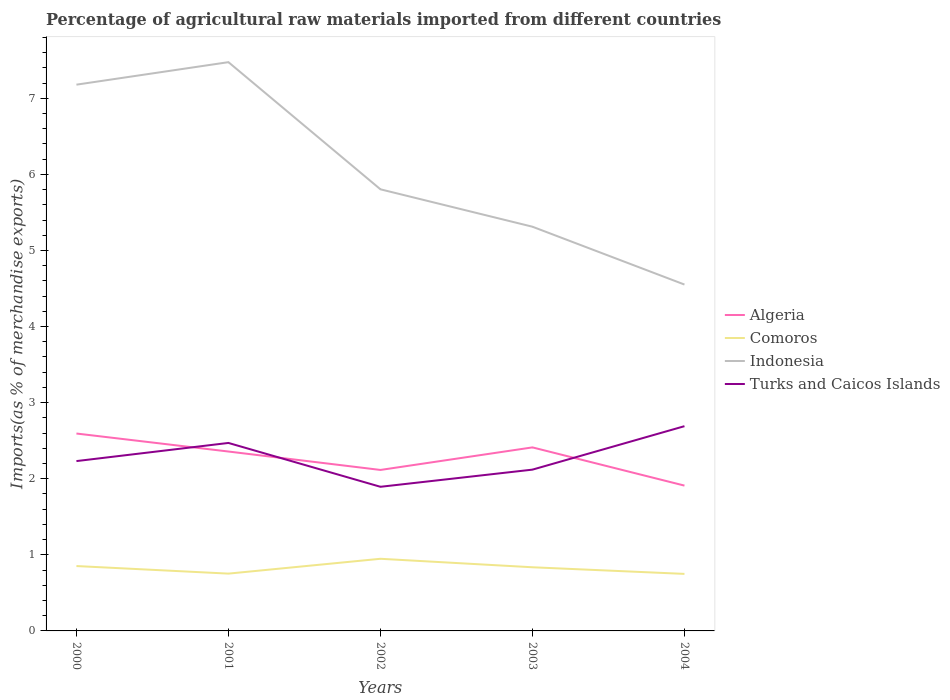How many different coloured lines are there?
Your answer should be compact. 4. Across all years, what is the maximum percentage of imports to different countries in Algeria?
Ensure brevity in your answer.  1.91. In which year was the percentage of imports to different countries in Indonesia maximum?
Ensure brevity in your answer.  2004. What is the total percentage of imports to different countries in Turks and Caicos Islands in the graph?
Ensure brevity in your answer.  0.58. What is the difference between the highest and the second highest percentage of imports to different countries in Algeria?
Provide a succinct answer. 0.68. Does the graph contain grids?
Give a very brief answer. No. Where does the legend appear in the graph?
Ensure brevity in your answer.  Center right. How are the legend labels stacked?
Ensure brevity in your answer.  Vertical. What is the title of the graph?
Keep it short and to the point. Percentage of agricultural raw materials imported from different countries. What is the label or title of the X-axis?
Make the answer very short. Years. What is the label or title of the Y-axis?
Your response must be concise. Imports(as % of merchandise exports). What is the Imports(as % of merchandise exports) in Algeria in 2000?
Provide a short and direct response. 2.59. What is the Imports(as % of merchandise exports) in Comoros in 2000?
Your answer should be very brief. 0.85. What is the Imports(as % of merchandise exports) of Indonesia in 2000?
Your answer should be compact. 7.18. What is the Imports(as % of merchandise exports) in Turks and Caicos Islands in 2000?
Make the answer very short. 2.23. What is the Imports(as % of merchandise exports) in Algeria in 2001?
Provide a succinct answer. 2.36. What is the Imports(as % of merchandise exports) in Comoros in 2001?
Keep it short and to the point. 0.75. What is the Imports(as % of merchandise exports) in Indonesia in 2001?
Provide a short and direct response. 7.47. What is the Imports(as % of merchandise exports) of Turks and Caicos Islands in 2001?
Provide a short and direct response. 2.47. What is the Imports(as % of merchandise exports) of Algeria in 2002?
Provide a short and direct response. 2.12. What is the Imports(as % of merchandise exports) in Comoros in 2002?
Provide a succinct answer. 0.95. What is the Imports(as % of merchandise exports) of Indonesia in 2002?
Your answer should be very brief. 5.8. What is the Imports(as % of merchandise exports) in Turks and Caicos Islands in 2002?
Ensure brevity in your answer.  1.89. What is the Imports(as % of merchandise exports) in Algeria in 2003?
Provide a succinct answer. 2.41. What is the Imports(as % of merchandise exports) of Comoros in 2003?
Provide a succinct answer. 0.84. What is the Imports(as % of merchandise exports) in Indonesia in 2003?
Make the answer very short. 5.31. What is the Imports(as % of merchandise exports) of Turks and Caicos Islands in 2003?
Keep it short and to the point. 2.12. What is the Imports(as % of merchandise exports) of Algeria in 2004?
Keep it short and to the point. 1.91. What is the Imports(as % of merchandise exports) in Comoros in 2004?
Your answer should be very brief. 0.75. What is the Imports(as % of merchandise exports) in Indonesia in 2004?
Your answer should be very brief. 4.55. What is the Imports(as % of merchandise exports) in Turks and Caicos Islands in 2004?
Offer a terse response. 2.69. Across all years, what is the maximum Imports(as % of merchandise exports) in Algeria?
Offer a very short reply. 2.59. Across all years, what is the maximum Imports(as % of merchandise exports) of Comoros?
Your answer should be very brief. 0.95. Across all years, what is the maximum Imports(as % of merchandise exports) in Indonesia?
Offer a very short reply. 7.47. Across all years, what is the maximum Imports(as % of merchandise exports) in Turks and Caicos Islands?
Your answer should be compact. 2.69. Across all years, what is the minimum Imports(as % of merchandise exports) in Algeria?
Keep it short and to the point. 1.91. Across all years, what is the minimum Imports(as % of merchandise exports) in Comoros?
Your response must be concise. 0.75. Across all years, what is the minimum Imports(as % of merchandise exports) in Indonesia?
Make the answer very short. 4.55. Across all years, what is the minimum Imports(as % of merchandise exports) of Turks and Caicos Islands?
Your answer should be compact. 1.89. What is the total Imports(as % of merchandise exports) in Algeria in the graph?
Your answer should be very brief. 11.39. What is the total Imports(as % of merchandise exports) of Comoros in the graph?
Provide a succinct answer. 4.14. What is the total Imports(as % of merchandise exports) of Indonesia in the graph?
Make the answer very short. 30.32. What is the total Imports(as % of merchandise exports) in Turks and Caicos Islands in the graph?
Your answer should be very brief. 11.41. What is the difference between the Imports(as % of merchandise exports) in Algeria in 2000 and that in 2001?
Provide a succinct answer. 0.24. What is the difference between the Imports(as % of merchandise exports) in Comoros in 2000 and that in 2001?
Give a very brief answer. 0.1. What is the difference between the Imports(as % of merchandise exports) in Indonesia in 2000 and that in 2001?
Offer a terse response. -0.3. What is the difference between the Imports(as % of merchandise exports) in Turks and Caicos Islands in 2000 and that in 2001?
Give a very brief answer. -0.24. What is the difference between the Imports(as % of merchandise exports) in Algeria in 2000 and that in 2002?
Provide a short and direct response. 0.48. What is the difference between the Imports(as % of merchandise exports) in Comoros in 2000 and that in 2002?
Give a very brief answer. -0.1. What is the difference between the Imports(as % of merchandise exports) of Indonesia in 2000 and that in 2002?
Offer a terse response. 1.38. What is the difference between the Imports(as % of merchandise exports) in Turks and Caicos Islands in 2000 and that in 2002?
Provide a short and direct response. 0.34. What is the difference between the Imports(as % of merchandise exports) of Algeria in 2000 and that in 2003?
Ensure brevity in your answer.  0.18. What is the difference between the Imports(as % of merchandise exports) in Comoros in 2000 and that in 2003?
Keep it short and to the point. 0.02. What is the difference between the Imports(as % of merchandise exports) in Indonesia in 2000 and that in 2003?
Ensure brevity in your answer.  1.87. What is the difference between the Imports(as % of merchandise exports) in Turks and Caicos Islands in 2000 and that in 2003?
Keep it short and to the point. 0.11. What is the difference between the Imports(as % of merchandise exports) in Algeria in 2000 and that in 2004?
Keep it short and to the point. 0.68. What is the difference between the Imports(as % of merchandise exports) in Comoros in 2000 and that in 2004?
Make the answer very short. 0.1. What is the difference between the Imports(as % of merchandise exports) in Indonesia in 2000 and that in 2004?
Give a very brief answer. 2.63. What is the difference between the Imports(as % of merchandise exports) of Turks and Caicos Islands in 2000 and that in 2004?
Ensure brevity in your answer.  -0.46. What is the difference between the Imports(as % of merchandise exports) of Algeria in 2001 and that in 2002?
Ensure brevity in your answer.  0.24. What is the difference between the Imports(as % of merchandise exports) of Comoros in 2001 and that in 2002?
Your answer should be compact. -0.2. What is the difference between the Imports(as % of merchandise exports) of Indonesia in 2001 and that in 2002?
Make the answer very short. 1.67. What is the difference between the Imports(as % of merchandise exports) of Turks and Caicos Islands in 2001 and that in 2002?
Provide a succinct answer. 0.58. What is the difference between the Imports(as % of merchandise exports) in Algeria in 2001 and that in 2003?
Ensure brevity in your answer.  -0.05. What is the difference between the Imports(as % of merchandise exports) in Comoros in 2001 and that in 2003?
Give a very brief answer. -0.08. What is the difference between the Imports(as % of merchandise exports) of Indonesia in 2001 and that in 2003?
Provide a short and direct response. 2.16. What is the difference between the Imports(as % of merchandise exports) of Turks and Caicos Islands in 2001 and that in 2003?
Your answer should be very brief. 0.35. What is the difference between the Imports(as % of merchandise exports) in Algeria in 2001 and that in 2004?
Your response must be concise. 0.45. What is the difference between the Imports(as % of merchandise exports) in Comoros in 2001 and that in 2004?
Provide a succinct answer. 0. What is the difference between the Imports(as % of merchandise exports) in Indonesia in 2001 and that in 2004?
Offer a terse response. 2.92. What is the difference between the Imports(as % of merchandise exports) of Turks and Caicos Islands in 2001 and that in 2004?
Offer a very short reply. -0.22. What is the difference between the Imports(as % of merchandise exports) in Algeria in 2002 and that in 2003?
Offer a very short reply. -0.3. What is the difference between the Imports(as % of merchandise exports) in Comoros in 2002 and that in 2003?
Offer a terse response. 0.11. What is the difference between the Imports(as % of merchandise exports) of Indonesia in 2002 and that in 2003?
Provide a short and direct response. 0.49. What is the difference between the Imports(as % of merchandise exports) in Turks and Caicos Islands in 2002 and that in 2003?
Give a very brief answer. -0.23. What is the difference between the Imports(as % of merchandise exports) in Algeria in 2002 and that in 2004?
Your answer should be compact. 0.21. What is the difference between the Imports(as % of merchandise exports) of Comoros in 2002 and that in 2004?
Make the answer very short. 0.2. What is the difference between the Imports(as % of merchandise exports) of Indonesia in 2002 and that in 2004?
Your response must be concise. 1.25. What is the difference between the Imports(as % of merchandise exports) in Turks and Caicos Islands in 2002 and that in 2004?
Make the answer very short. -0.8. What is the difference between the Imports(as % of merchandise exports) of Algeria in 2003 and that in 2004?
Provide a short and direct response. 0.5. What is the difference between the Imports(as % of merchandise exports) of Comoros in 2003 and that in 2004?
Give a very brief answer. 0.09. What is the difference between the Imports(as % of merchandise exports) in Indonesia in 2003 and that in 2004?
Your answer should be compact. 0.76. What is the difference between the Imports(as % of merchandise exports) of Turks and Caicos Islands in 2003 and that in 2004?
Keep it short and to the point. -0.57. What is the difference between the Imports(as % of merchandise exports) in Algeria in 2000 and the Imports(as % of merchandise exports) in Comoros in 2001?
Ensure brevity in your answer.  1.84. What is the difference between the Imports(as % of merchandise exports) in Algeria in 2000 and the Imports(as % of merchandise exports) in Indonesia in 2001?
Your response must be concise. -4.88. What is the difference between the Imports(as % of merchandise exports) of Algeria in 2000 and the Imports(as % of merchandise exports) of Turks and Caicos Islands in 2001?
Offer a terse response. 0.12. What is the difference between the Imports(as % of merchandise exports) of Comoros in 2000 and the Imports(as % of merchandise exports) of Indonesia in 2001?
Give a very brief answer. -6.62. What is the difference between the Imports(as % of merchandise exports) of Comoros in 2000 and the Imports(as % of merchandise exports) of Turks and Caicos Islands in 2001?
Make the answer very short. -1.62. What is the difference between the Imports(as % of merchandise exports) of Indonesia in 2000 and the Imports(as % of merchandise exports) of Turks and Caicos Islands in 2001?
Your response must be concise. 4.71. What is the difference between the Imports(as % of merchandise exports) in Algeria in 2000 and the Imports(as % of merchandise exports) in Comoros in 2002?
Your answer should be very brief. 1.65. What is the difference between the Imports(as % of merchandise exports) in Algeria in 2000 and the Imports(as % of merchandise exports) in Indonesia in 2002?
Keep it short and to the point. -3.21. What is the difference between the Imports(as % of merchandise exports) in Algeria in 2000 and the Imports(as % of merchandise exports) in Turks and Caicos Islands in 2002?
Keep it short and to the point. 0.7. What is the difference between the Imports(as % of merchandise exports) in Comoros in 2000 and the Imports(as % of merchandise exports) in Indonesia in 2002?
Keep it short and to the point. -4.95. What is the difference between the Imports(as % of merchandise exports) of Comoros in 2000 and the Imports(as % of merchandise exports) of Turks and Caicos Islands in 2002?
Give a very brief answer. -1.04. What is the difference between the Imports(as % of merchandise exports) in Indonesia in 2000 and the Imports(as % of merchandise exports) in Turks and Caicos Islands in 2002?
Your answer should be compact. 5.28. What is the difference between the Imports(as % of merchandise exports) of Algeria in 2000 and the Imports(as % of merchandise exports) of Comoros in 2003?
Your answer should be very brief. 1.76. What is the difference between the Imports(as % of merchandise exports) in Algeria in 2000 and the Imports(as % of merchandise exports) in Indonesia in 2003?
Provide a short and direct response. -2.72. What is the difference between the Imports(as % of merchandise exports) in Algeria in 2000 and the Imports(as % of merchandise exports) in Turks and Caicos Islands in 2003?
Offer a terse response. 0.47. What is the difference between the Imports(as % of merchandise exports) of Comoros in 2000 and the Imports(as % of merchandise exports) of Indonesia in 2003?
Provide a succinct answer. -4.46. What is the difference between the Imports(as % of merchandise exports) of Comoros in 2000 and the Imports(as % of merchandise exports) of Turks and Caicos Islands in 2003?
Make the answer very short. -1.27. What is the difference between the Imports(as % of merchandise exports) in Indonesia in 2000 and the Imports(as % of merchandise exports) in Turks and Caicos Islands in 2003?
Give a very brief answer. 5.06. What is the difference between the Imports(as % of merchandise exports) of Algeria in 2000 and the Imports(as % of merchandise exports) of Comoros in 2004?
Provide a succinct answer. 1.84. What is the difference between the Imports(as % of merchandise exports) in Algeria in 2000 and the Imports(as % of merchandise exports) in Indonesia in 2004?
Offer a very short reply. -1.96. What is the difference between the Imports(as % of merchandise exports) in Algeria in 2000 and the Imports(as % of merchandise exports) in Turks and Caicos Islands in 2004?
Ensure brevity in your answer.  -0.1. What is the difference between the Imports(as % of merchandise exports) of Comoros in 2000 and the Imports(as % of merchandise exports) of Indonesia in 2004?
Keep it short and to the point. -3.7. What is the difference between the Imports(as % of merchandise exports) of Comoros in 2000 and the Imports(as % of merchandise exports) of Turks and Caicos Islands in 2004?
Keep it short and to the point. -1.84. What is the difference between the Imports(as % of merchandise exports) of Indonesia in 2000 and the Imports(as % of merchandise exports) of Turks and Caicos Islands in 2004?
Offer a terse response. 4.49. What is the difference between the Imports(as % of merchandise exports) in Algeria in 2001 and the Imports(as % of merchandise exports) in Comoros in 2002?
Give a very brief answer. 1.41. What is the difference between the Imports(as % of merchandise exports) of Algeria in 2001 and the Imports(as % of merchandise exports) of Indonesia in 2002?
Your response must be concise. -3.45. What is the difference between the Imports(as % of merchandise exports) of Algeria in 2001 and the Imports(as % of merchandise exports) of Turks and Caicos Islands in 2002?
Provide a short and direct response. 0.46. What is the difference between the Imports(as % of merchandise exports) of Comoros in 2001 and the Imports(as % of merchandise exports) of Indonesia in 2002?
Keep it short and to the point. -5.05. What is the difference between the Imports(as % of merchandise exports) of Comoros in 2001 and the Imports(as % of merchandise exports) of Turks and Caicos Islands in 2002?
Provide a short and direct response. -1.14. What is the difference between the Imports(as % of merchandise exports) of Indonesia in 2001 and the Imports(as % of merchandise exports) of Turks and Caicos Islands in 2002?
Offer a very short reply. 5.58. What is the difference between the Imports(as % of merchandise exports) in Algeria in 2001 and the Imports(as % of merchandise exports) in Comoros in 2003?
Offer a very short reply. 1.52. What is the difference between the Imports(as % of merchandise exports) in Algeria in 2001 and the Imports(as % of merchandise exports) in Indonesia in 2003?
Provide a succinct answer. -2.95. What is the difference between the Imports(as % of merchandise exports) of Algeria in 2001 and the Imports(as % of merchandise exports) of Turks and Caicos Islands in 2003?
Your answer should be compact. 0.24. What is the difference between the Imports(as % of merchandise exports) in Comoros in 2001 and the Imports(as % of merchandise exports) in Indonesia in 2003?
Your answer should be very brief. -4.56. What is the difference between the Imports(as % of merchandise exports) of Comoros in 2001 and the Imports(as % of merchandise exports) of Turks and Caicos Islands in 2003?
Your answer should be compact. -1.37. What is the difference between the Imports(as % of merchandise exports) of Indonesia in 2001 and the Imports(as % of merchandise exports) of Turks and Caicos Islands in 2003?
Provide a succinct answer. 5.35. What is the difference between the Imports(as % of merchandise exports) of Algeria in 2001 and the Imports(as % of merchandise exports) of Comoros in 2004?
Make the answer very short. 1.61. What is the difference between the Imports(as % of merchandise exports) of Algeria in 2001 and the Imports(as % of merchandise exports) of Indonesia in 2004?
Keep it short and to the point. -2.19. What is the difference between the Imports(as % of merchandise exports) in Algeria in 2001 and the Imports(as % of merchandise exports) in Turks and Caicos Islands in 2004?
Your answer should be compact. -0.33. What is the difference between the Imports(as % of merchandise exports) in Comoros in 2001 and the Imports(as % of merchandise exports) in Indonesia in 2004?
Provide a succinct answer. -3.8. What is the difference between the Imports(as % of merchandise exports) in Comoros in 2001 and the Imports(as % of merchandise exports) in Turks and Caicos Islands in 2004?
Your answer should be very brief. -1.94. What is the difference between the Imports(as % of merchandise exports) in Indonesia in 2001 and the Imports(as % of merchandise exports) in Turks and Caicos Islands in 2004?
Ensure brevity in your answer.  4.78. What is the difference between the Imports(as % of merchandise exports) in Algeria in 2002 and the Imports(as % of merchandise exports) in Comoros in 2003?
Provide a short and direct response. 1.28. What is the difference between the Imports(as % of merchandise exports) of Algeria in 2002 and the Imports(as % of merchandise exports) of Indonesia in 2003?
Offer a terse response. -3.2. What is the difference between the Imports(as % of merchandise exports) of Algeria in 2002 and the Imports(as % of merchandise exports) of Turks and Caicos Islands in 2003?
Your answer should be very brief. -0. What is the difference between the Imports(as % of merchandise exports) in Comoros in 2002 and the Imports(as % of merchandise exports) in Indonesia in 2003?
Keep it short and to the point. -4.36. What is the difference between the Imports(as % of merchandise exports) of Comoros in 2002 and the Imports(as % of merchandise exports) of Turks and Caicos Islands in 2003?
Your response must be concise. -1.17. What is the difference between the Imports(as % of merchandise exports) of Indonesia in 2002 and the Imports(as % of merchandise exports) of Turks and Caicos Islands in 2003?
Provide a succinct answer. 3.68. What is the difference between the Imports(as % of merchandise exports) of Algeria in 2002 and the Imports(as % of merchandise exports) of Comoros in 2004?
Ensure brevity in your answer.  1.37. What is the difference between the Imports(as % of merchandise exports) of Algeria in 2002 and the Imports(as % of merchandise exports) of Indonesia in 2004?
Offer a very short reply. -2.44. What is the difference between the Imports(as % of merchandise exports) of Algeria in 2002 and the Imports(as % of merchandise exports) of Turks and Caicos Islands in 2004?
Give a very brief answer. -0.58. What is the difference between the Imports(as % of merchandise exports) in Comoros in 2002 and the Imports(as % of merchandise exports) in Indonesia in 2004?
Offer a terse response. -3.6. What is the difference between the Imports(as % of merchandise exports) in Comoros in 2002 and the Imports(as % of merchandise exports) in Turks and Caicos Islands in 2004?
Your answer should be very brief. -1.74. What is the difference between the Imports(as % of merchandise exports) in Indonesia in 2002 and the Imports(as % of merchandise exports) in Turks and Caicos Islands in 2004?
Your answer should be compact. 3.11. What is the difference between the Imports(as % of merchandise exports) in Algeria in 2003 and the Imports(as % of merchandise exports) in Comoros in 2004?
Offer a very short reply. 1.66. What is the difference between the Imports(as % of merchandise exports) in Algeria in 2003 and the Imports(as % of merchandise exports) in Indonesia in 2004?
Give a very brief answer. -2.14. What is the difference between the Imports(as % of merchandise exports) in Algeria in 2003 and the Imports(as % of merchandise exports) in Turks and Caicos Islands in 2004?
Provide a short and direct response. -0.28. What is the difference between the Imports(as % of merchandise exports) of Comoros in 2003 and the Imports(as % of merchandise exports) of Indonesia in 2004?
Offer a very short reply. -3.72. What is the difference between the Imports(as % of merchandise exports) in Comoros in 2003 and the Imports(as % of merchandise exports) in Turks and Caicos Islands in 2004?
Provide a short and direct response. -1.85. What is the difference between the Imports(as % of merchandise exports) in Indonesia in 2003 and the Imports(as % of merchandise exports) in Turks and Caicos Islands in 2004?
Your answer should be very brief. 2.62. What is the average Imports(as % of merchandise exports) in Algeria per year?
Your answer should be compact. 2.28. What is the average Imports(as % of merchandise exports) of Comoros per year?
Make the answer very short. 0.83. What is the average Imports(as % of merchandise exports) of Indonesia per year?
Your answer should be compact. 6.06. What is the average Imports(as % of merchandise exports) of Turks and Caicos Islands per year?
Provide a succinct answer. 2.28. In the year 2000, what is the difference between the Imports(as % of merchandise exports) of Algeria and Imports(as % of merchandise exports) of Comoros?
Ensure brevity in your answer.  1.74. In the year 2000, what is the difference between the Imports(as % of merchandise exports) of Algeria and Imports(as % of merchandise exports) of Indonesia?
Your answer should be very brief. -4.58. In the year 2000, what is the difference between the Imports(as % of merchandise exports) of Algeria and Imports(as % of merchandise exports) of Turks and Caicos Islands?
Provide a succinct answer. 0.36. In the year 2000, what is the difference between the Imports(as % of merchandise exports) of Comoros and Imports(as % of merchandise exports) of Indonesia?
Offer a terse response. -6.33. In the year 2000, what is the difference between the Imports(as % of merchandise exports) of Comoros and Imports(as % of merchandise exports) of Turks and Caicos Islands?
Provide a short and direct response. -1.38. In the year 2000, what is the difference between the Imports(as % of merchandise exports) in Indonesia and Imports(as % of merchandise exports) in Turks and Caicos Islands?
Provide a short and direct response. 4.95. In the year 2001, what is the difference between the Imports(as % of merchandise exports) in Algeria and Imports(as % of merchandise exports) in Comoros?
Provide a short and direct response. 1.6. In the year 2001, what is the difference between the Imports(as % of merchandise exports) in Algeria and Imports(as % of merchandise exports) in Indonesia?
Your answer should be very brief. -5.12. In the year 2001, what is the difference between the Imports(as % of merchandise exports) of Algeria and Imports(as % of merchandise exports) of Turks and Caicos Islands?
Keep it short and to the point. -0.11. In the year 2001, what is the difference between the Imports(as % of merchandise exports) of Comoros and Imports(as % of merchandise exports) of Indonesia?
Offer a very short reply. -6.72. In the year 2001, what is the difference between the Imports(as % of merchandise exports) in Comoros and Imports(as % of merchandise exports) in Turks and Caicos Islands?
Your answer should be very brief. -1.72. In the year 2001, what is the difference between the Imports(as % of merchandise exports) of Indonesia and Imports(as % of merchandise exports) of Turks and Caicos Islands?
Provide a short and direct response. 5. In the year 2002, what is the difference between the Imports(as % of merchandise exports) of Algeria and Imports(as % of merchandise exports) of Comoros?
Keep it short and to the point. 1.17. In the year 2002, what is the difference between the Imports(as % of merchandise exports) in Algeria and Imports(as % of merchandise exports) in Indonesia?
Ensure brevity in your answer.  -3.69. In the year 2002, what is the difference between the Imports(as % of merchandise exports) of Algeria and Imports(as % of merchandise exports) of Turks and Caicos Islands?
Your answer should be compact. 0.22. In the year 2002, what is the difference between the Imports(as % of merchandise exports) of Comoros and Imports(as % of merchandise exports) of Indonesia?
Provide a succinct answer. -4.86. In the year 2002, what is the difference between the Imports(as % of merchandise exports) in Comoros and Imports(as % of merchandise exports) in Turks and Caicos Islands?
Ensure brevity in your answer.  -0.95. In the year 2002, what is the difference between the Imports(as % of merchandise exports) of Indonesia and Imports(as % of merchandise exports) of Turks and Caicos Islands?
Your response must be concise. 3.91. In the year 2003, what is the difference between the Imports(as % of merchandise exports) in Algeria and Imports(as % of merchandise exports) in Comoros?
Provide a short and direct response. 1.58. In the year 2003, what is the difference between the Imports(as % of merchandise exports) in Algeria and Imports(as % of merchandise exports) in Turks and Caicos Islands?
Give a very brief answer. 0.29. In the year 2003, what is the difference between the Imports(as % of merchandise exports) of Comoros and Imports(as % of merchandise exports) of Indonesia?
Your response must be concise. -4.48. In the year 2003, what is the difference between the Imports(as % of merchandise exports) of Comoros and Imports(as % of merchandise exports) of Turks and Caicos Islands?
Your answer should be compact. -1.28. In the year 2003, what is the difference between the Imports(as % of merchandise exports) in Indonesia and Imports(as % of merchandise exports) in Turks and Caicos Islands?
Your answer should be compact. 3.19. In the year 2004, what is the difference between the Imports(as % of merchandise exports) of Algeria and Imports(as % of merchandise exports) of Comoros?
Your answer should be very brief. 1.16. In the year 2004, what is the difference between the Imports(as % of merchandise exports) of Algeria and Imports(as % of merchandise exports) of Indonesia?
Offer a very short reply. -2.64. In the year 2004, what is the difference between the Imports(as % of merchandise exports) in Algeria and Imports(as % of merchandise exports) in Turks and Caicos Islands?
Offer a terse response. -0.78. In the year 2004, what is the difference between the Imports(as % of merchandise exports) of Comoros and Imports(as % of merchandise exports) of Indonesia?
Offer a terse response. -3.8. In the year 2004, what is the difference between the Imports(as % of merchandise exports) of Comoros and Imports(as % of merchandise exports) of Turks and Caicos Islands?
Ensure brevity in your answer.  -1.94. In the year 2004, what is the difference between the Imports(as % of merchandise exports) in Indonesia and Imports(as % of merchandise exports) in Turks and Caicos Islands?
Provide a succinct answer. 1.86. What is the ratio of the Imports(as % of merchandise exports) in Algeria in 2000 to that in 2001?
Keep it short and to the point. 1.1. What is the ratio of the Imports(as % of merchandise exports) of Comoros in 2000 to that in 2001?
Ensure brevity in your answer.  1.13. What is the ratio of the Imports(as % of merchandise exports) of Indonesia in 2000 to that in 2001?
Your answer should be very brief. 0.96. What is the ratio of the Imports(as % of merchandise exports) of Turks and Caicos Islands in 2000 to that in 2001?
Your answer should be very brief. 0.9. What is the ratio of the Imports(as % of merchandise exports) of Algeria in 2000 to that in 2002?
Give a very brief answer. 1.23. What is the ratio of the Imports(as % of merchandise exports) of Comoros in 2000 to that in 2002?
Ensure brevity in your answer.  0.9. What is the ratio of the Imports(as % of merchandise exports) in Indonesia in 2000 to that in 2002?
Give a very brief answer. 1.24. What is the ratio of the Imports(as % of merchandise exports) of Turks and Caicos Islands in 2000 to that in 2002?
Provide a succinct answer. 1.18. What is the ratio of the Imports(as % of merchandise exports) in Algeria in 2000 to that in 2003?
Offer a terse response. 1.08. What is the ratio of the Imports(as % of merchandise exports) in Comoros in 2000 to that in 2003?
Your response must be concise. 1.02. What is the ratio of the Imports(as % of merchandise exports) of Indonesia in 2000 to that in 2003?
Your answer should be very brief. 1.35. What is the ratio of the Imports(as % of merchandise exports) in Turks and Caicos Islands in 2000 to that in 2003?
Keep it short and to the point. 1.05. What is the ratio of the Imports(as % of merchandise exports) in Algeria in 2000 to that in 2004?
Provide a short and direct response. 1.36. What is the ratio of the Imports(as % of merchandise exports) in Comoros in 2000 to that in 2004?
Offer a very short reply. 1.14. What is the ratio of the Imports(as % of merchandise exports) of Indonesia in 2000 to that in 2004?
Your answer should be very brief. 1.58. What is the ratio of the Imports(as % of merchandise exports) in Turks and Caicos Islands in 2000 to that in 2004?
Give a very brief answer. 0.83. What is the ratio of the Imports(as % of merchandise exports) of Algeria in 2001 to that in 2002?
Give a very brief answer. 1.11. What is the ratio of the Imports(as % of merchandise exports) in Comoros in 2001 to that in 2002?
Your answer should be compact. 0.79. What is the ratio of the Imports(as % of merchandise exports) in Indonesia in 2001 to that in 2002?
Keep it short and to the point. 1.29. What is the ratio of the Imports(as % of merchandise exports) in Turks and Caicos Islands in 2001 to that in 2002?
Your response must be concise. 1.3. What is the ratio of the Imports(as % of merchandise exports) of Algeria in 2001 to that in 2003?
Provide a short and direct response. 0.98. What is the ratio of the Imports(as % of merchandise exports) in Comoros in 2001 to that in 2003?
Give a very brief answer. 0.9. What is the ratio of the Imports(as % of merchandise exports) of Indonesia in 2001 to that in 2003?
Offer a terse response. 1.41. What is the ratio of the Imports(as % of merchandise exports) in Turks and Caicos Islands in 2001 to that in 2003?
Keep it short and to the point. 1.17. What is the ratio of the Imports(as % of merchandise exports) of Algeria in 2001 to that in 2004?
Offer a terse response. 1.23. What is the ratio of the Imports(as % of merchandise exports) in Indonesia in 2001 to that in 2004?
Your response must be concise. 1.64. What is the ratio of the Imports(as % of merchandise exports) in Turks and Caicos Islands in 2001 to that in 2004?
Provide a succinct answer. 0.92. What is the ratio of the Imports(as % of merchandise exports) of Algeria in 2002 to that in 2003?
Ensure brevity in your answer.  0.88. What is the ratio of the Imports(as % of merchandise exports) of Comoros in 2002 to that in 2003?
Offer a terse response. 1.13. What is the ratio of the Imports(as % of merchandise exports) of Indonesia in 2002 to that in 2003?
Ensure brevity in your answer.  1.09. What is the ratio of the Imports(as % of merchandise exports) in Turks and Caicos Islands in 2002 to that in 2003?
Provide a succinct answer. 0.89. What is the ratio of the Imports(as % of merchandise exports) of Algeria in 2002 to that in 2004?
Your response must be concise. 1.11. What is the ratio of the Imports(as % of merchandise exports) of Comoros in 2002 to that in 2004?
Your response must be concise. 1.26. What is the ratio of the Imports(as % of merchandise exports) of Indonesia in 2002 to that in 2004?
Make the answer very short. 1.27. What is the ratio of the Imports(as % of merchandise exports) in Turks and Caicos Islands in 2002 to that in 2004?
Offer a terse response. 0.7. What is the ratio of the Imports(as % of merchandise exports) in Algeria in 2003 to that in 2004?
Keep it short and to the point. 1.26. What is the ratio of the Imports(as % of merchandise exports) of Comoros in 2003 to that in 2004?
Your answer should be very brief. 1.12. What is the ratio of the Imports(as % of merchandise exports) of Indonesia in 2003 to that in 2004?
Provide a short and direct response. 1.17. What is the ratio of the Imports(as % of merchandise exports) in Turks and Caicos Islands in 2003 to that in 2004?
Offer a very short reply. 0.79. What is the difference between the highest and the second highest Imports(as % of merchandise exports) of Algeria?
Ensure brevity in your answer.  0.18. What is the difference between the highest and the second highest Imports(as % of merchandise exports) of Comoros?
Offer a terse response. 0.1. What is the difference between the highest and the second highest Imports(as % of merchandise exports) of Indonesia?
Your response must be concise. 0.3. What is the difference between the highest and the second highest Imports(as % of merchandise exports) of Turks and Caicos Islands?
Your answer should be very brief. 0.22. What is the difference between the highest and the lowest Imports(as % of merchandise exports) in Algeria?
Provide a short and direct response. 0.68. What is the difference between the highest and the lowest Imports(as % of merchandise exports) of Comoros?
Ensure brevity in your answer.  0.2. What is the difference between the highest and the lowest Imports(as % of merchandise exports) of Indonesia?
Offer a very short reply. 2.92. What is the difference between the highest and the lowest Imports(as % of merchandise exports) of Turks and Caicos Islands?
Your answer should be very brief. 0.8. 